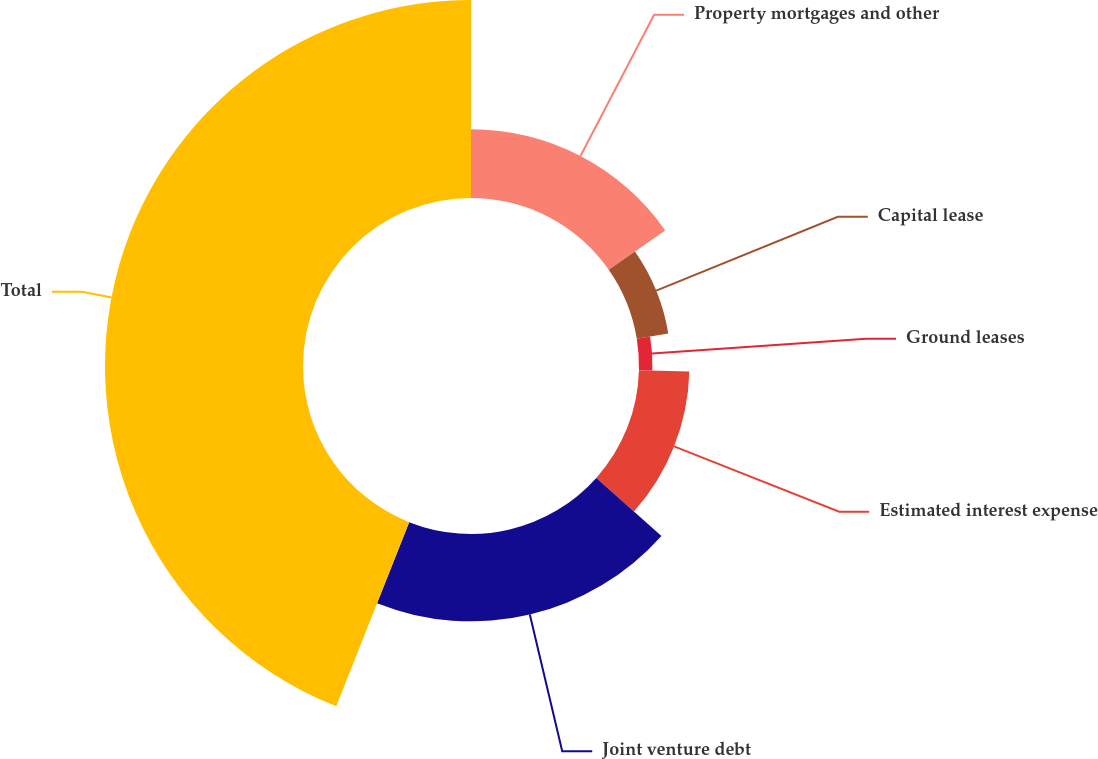<chart> <loc_0><loc_0><loc_500><loc_500><pie_chart><fcel>Property mortgages and other<fcel>Capital lease<fcel>Ground leases<fcel>Estimated interest expense<fcel>Joint venture debt<fcel>Total<nl><fcel>15.3%<fcel>7.1%<fcel>3.0%<fcel>11.2%<fcel>19.4%<fcel>44.0%<nl></chart> 